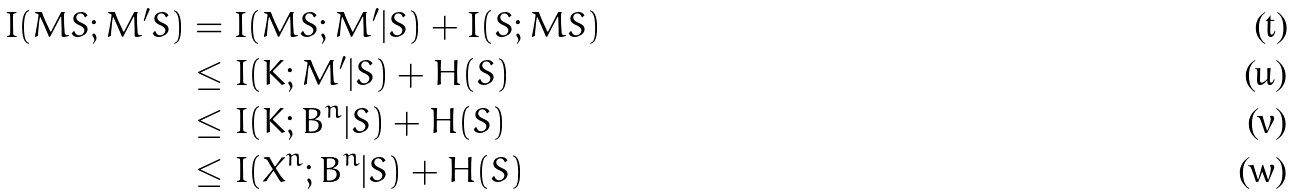Convert formula to latex. <formula><loc_0><loc_0><loc_500><loc_500>I ( M S ; M ^ { \prime } S ) & = I ( M S ; M ^ { \prime } | S ) + I ( S ; M S ) \\ & \leq I ( K ; M ^ { \prime } | S ) + H ( S ) \\ & \leq I ( K ; B ^ { n } | S ) + H ( S ) \\ & \leq I ( X ^ { n } ; B ^ { n } | S ) + H ( S )</formula> 